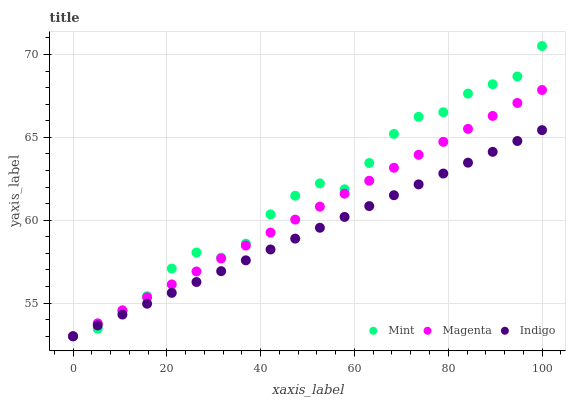Does Indigo have the minimum area under the curve?
Answer yes or no. Yes. Does Mint have the maximum area under the curve?
Answer yes or no. Yes. Does Magenta have the minimum area under the curve?
Answer yes or no. No. Does Magenta have the maximum area under the curve?
Answer yes or no. No. Is Magenta the smoothest?
Answer yes or no. Yes. Is Mint the roughest?
Answer yes or no. Yes. Is Mint the smoothest?
Answer yes or no. No. Is Magenta the roughest?
Answer yes or no. No. Does Indigo have the lowest value?
Answer yes or no. Yes. Does Mint have the highest value?
Answer yes or no. Yes. Does Magenta have the highest value?
Answer yes or no. No. Does Indigo intersect Magenta?
Answer yes or no. Yes. Is Indigo less than Magenta?
Answer yes or no. No. Is Indigo greater than Magenta?
Answer yes or no. No. 